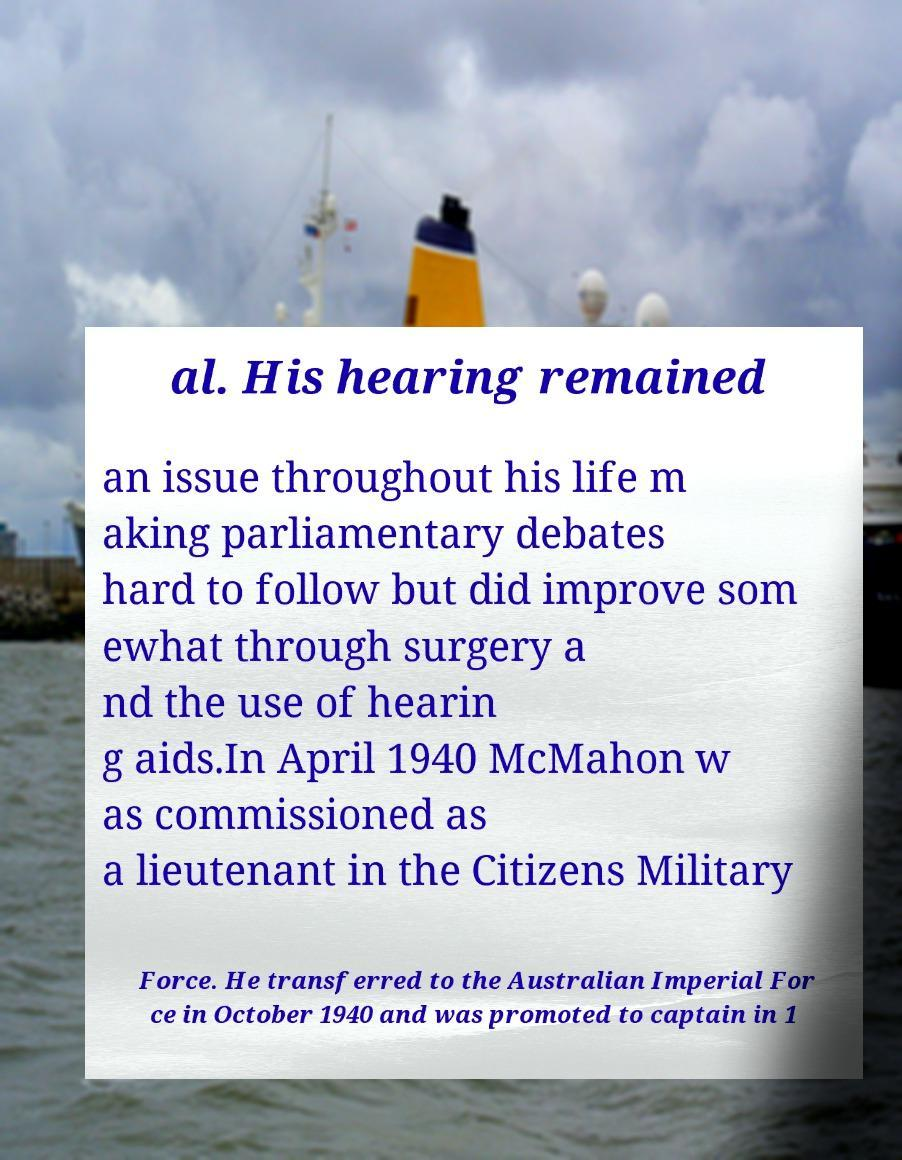For documentation purposes, I need the text within this image transcribed. Could you provide that? al. His hearing remained an issue throughout his life m aking parliamentary debates hard to follow but did improve som ewhat through surgery a nd the use of hearin g aids.In April 1940 McMahon w as commissioned as a lieutenant in the Citizens Military Force. He transferred to the Australian Imperial For ce in October 1940 and was promoted to captain in 1 